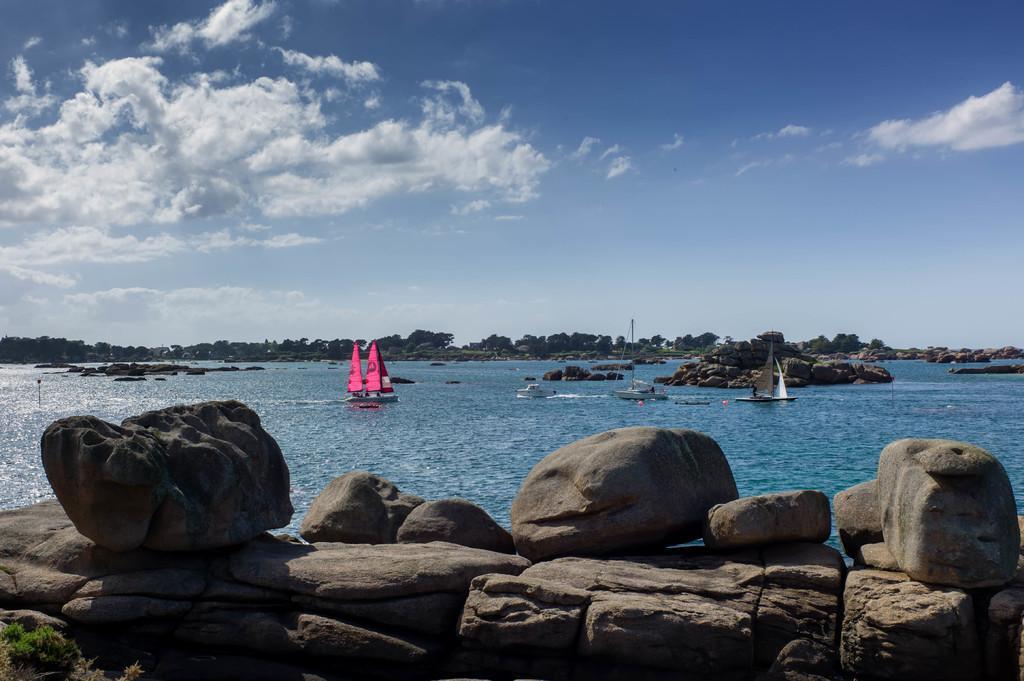Please provide a concise description of this image. In this image there are some stones in the bottom of this image and on the right side of this image as well. There is a Sea in the middle of this image and there are some boats on it. There is a cloudy sky on the top of this image. There are some trees in the middle of this image. 